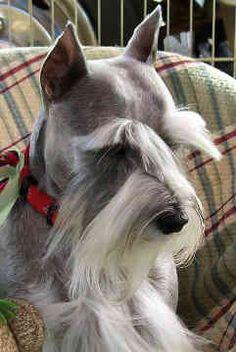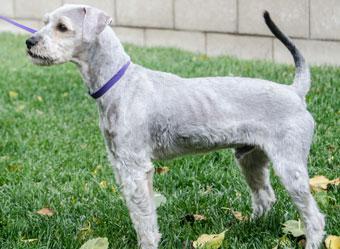The first image is the image on the left, the second image is the image on the right. Given the left and right images, does the statement "the dog in the image on the right is wearing a collar" hold true? Answer yes or no. Yes. The first image is the image on the left, the second image is the image on the right. Assess this claim about the two images: "Schnauzer in the left image is wearing a kind of bandana around its neck.". Correct or not? Answer yes or no. No. 